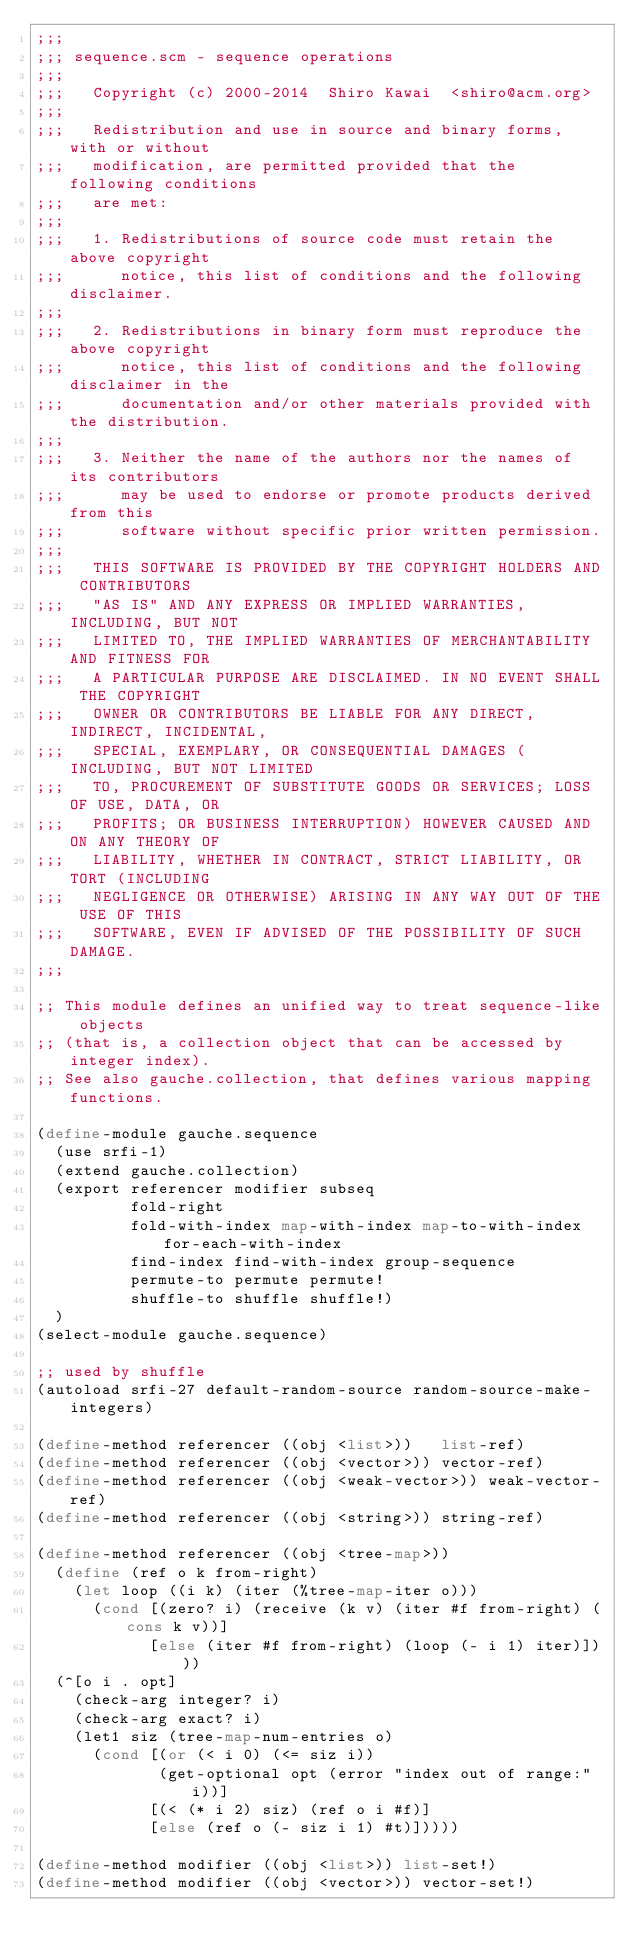Convert code to text. <code><loc_0><loc_0><loc_500><loc_500><_Scheme_>;;;
;;; sequence.scm - sequence operations
;;;
;;;   Copyright (c) 2000-2014  Shiro Kawai  <shiro@acm.org>
;;;
;;;   Redistribution and use in source and binary forms, with or without
;;;   modification, are permitted provided that the following conditions
;;;   are met:
;;;
;;;   1. Redistributions of source code must retain the above copyright
;;;      notice, this list of conditions and the following disclaimer.
;;;
;;;   2. Redistributions in binary form must reproduce the above copyright
;;;      notice, this list of conditions and the following disclaimer in the
;;;      documentation and/or other materials provided with the distribution.
;;;
;;;   3. Neither the name of the authors nor the names of its contributors
;;;      may be used to endorse or promote products derived from this
;;;      software without specific prior written permission.
;;;
;;;   THIS SOFTWARE IS PROVIDED BY THE COPYRIGHT HOLDERS AND CONTRIBUTORS
;;;   "AS IS" AND ANY EXPRESS OR IMPLIED WARRANTIES, INCLUDING, BUT NOT
;;;   LIMITED TO, THE IMPLIED WARRANTIES OF MERCHANTABILITY AND FITNESS FOR
;;;   A PARTICULAR PURPOSE ARE DISCLAIMED. IN NO EVENT SHALL THE COPYRIGHT
;;;   OWNER OR CONTRIBUTORS BE LIABLE FOR ANY DIRECT, INDIRECT, INCIDENTAL,
;;;   SPECIAL, EXEMPLARY, OR CONSEQUENTIAL DAMAGES (INCLUDING, BUT NOT LIMITED
;;;   TO, PROCUREMENT OF SUBSTITUTE GOODS OR SERVICES; LOSS OF USE, DATA, OR
;;;   PROFITS; OR BUSINESS INTERRUPTION) HOWEVER CAUSED AND ON ANY THEORY OF
;;;   LIABILITY, WHETHER IN CONTRACT, STRICT LIABILITY, OR TORT (INCLUDING
;;;   NEGLIGENCE OR OTHERWISE) ARISING IN ANY WAY OUT OF THE USE OF THIS
;;;   SOFTWARE, EVEN IF ADVISED OF THE POSSIBILITY OF SUCH DAMAGE.
;;;

;; This module defines an unified way to treat sequence-like objects
;; (that is, a collection object that can be accessed by integer index).
;; See also gauche.collection, that defines various mapping functions.

(define-module gauche.sequence
  (use srfi-1)
  (extend gauche.collection)
  (export referencer modifier subseq
          fold-right
          fold-with-index map-with-index map-to-with-index for-each-with-index
          find-index find-with-index group-sequence
          permute-to permute permute!
          shuffle-to shuffle shuffle!)
  )
(select-module gauche.sequence)

;; used by shuffle
(autoload srfi-27 default-random-source random-source-make-integers)

(define-method referencer ((obj <list>))   list-ref)
(define-method referencer ((obj <vector>)) vector-ref)
(define-method referencer ((obj <weak-vector>)) weak-vector-ref)
(define-method referencer ((obj <string>)) string-ref)

(define-method referencer ((obj <tree-map>))
  (define (ref o k from-right)
    (let loop ((i k) (iter (%tree-map-iter o)))
      (cond [(zero? i) (receive (k v) (iter #f from-right) (cons k v))]
            [else (iter #f from-right) (loop (- i 1) iter)])))
  (^[o i . opt]
    (check-arg integer? i)
    (check-arg exact? i)
    (let1 siz (tree-map-num-entries o)
      (cond [(or (< i 0) (<= siz i))
             (get-optional opt (error "index out of range:" i))]
            [(< (* i 2) siz) (ref o i #f)]
            [else (ref o (- siz i 1) #t)]))))

(define-method modifier ((obj <list>)) list-set!)
(define-method modifier ((obj <vector>)) vector-set!)</code> 